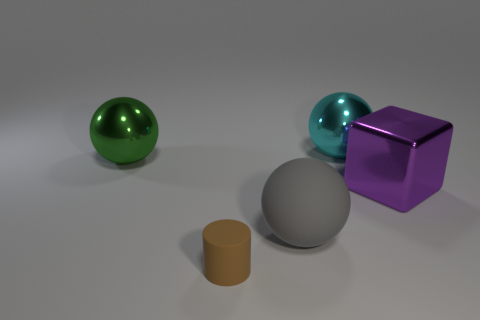How many things are either cyan metal things or brown cylinders?
Give a very brief answer. 2. There is a green shiny thing; is its size the same as the ball that is in front of the purple metal cube?
Offer a terse response. Yes. The ball in front of the big block in front of the sphere to the left of the large matte ball is what color?
Your response must be concise. Gray. The cube is what color?
Keep it short and to the point. Purple. Is the number of cylinders in front of the cyan thing greater than the number of large green objects in front of the gray matte sphere?
Your response must be concise. Yes. Do the cyan thing and the big thing on the left side of the gray rubber ball have the same shape?
Your response must be concise. Yes. Is the size of the sphere in front of the purple shiny thing the same as the matte thing that is to the left of the large gray thing?
Make the answer very short. No. Are there any big objects on the right side of the metal object that is left of the big sphere behind the big green metal object?
Your answer should be very brief. Yes. Are there fewer brown cylinders to the left of the large green metal sphere than objects that are in front of the big matte ball?
Your answer should be compact. Yes. There is a green thing that is the same material as the big purple thing; what is its shape?
Offer a very short reply. Sphere. 